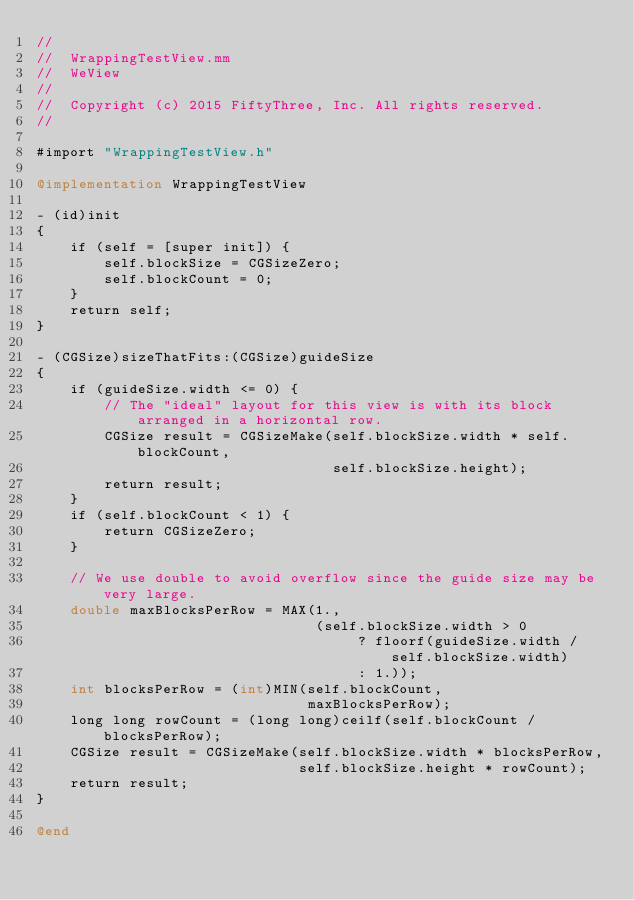<code> <loc_0><loc_0><loc_500><loc_500><_ObjectiveC_>//
//  WrappingTestView.mm
//  WeView
//
//  Copyright (c) 2015 FiftyThree, Inc. All rights reserved.
//

#import "WrappingTestView.h"

@implementation WrappingTestView

- (id)init
{
    if (self = [super init]) {
        self.blockSize = CGSizeZero;
        self.blockCount = 0;
    }
    return self;
}

- (CGSize)sizeThatFits:(CGSize)guideSize
{
    if (guideSize.width <= 0) {
        // The "ideal" layout for this view is with its block arranged in a horizontal row.
        CGSize result = CGSizeMake(self.blockSize.width * self.blockCount,
                                   self.blockSize.height);
        return result;
    }
    if (self.blockCount < 1) {
        return CGSizeZero;
    }

    // We use double to avoid overflow since the guide size may be very large.
    double maxBlocksPerRow = MAX(1.,
                                 (self.blockSize.width > 0
                                      ? floorf(guideSize.width / self.blockSize.width)
                                      : 1.));
    int blocksPerRow = (int)MIN(self.blockCount,
                                maxBlocksPerRow);
    long long rowCount = (long long)ceilf(self.blockCount / blocksPerRow);
    CGSize result = CGSizeMake(self.blockSize.width * blocksPerRow,
                               self.blockSize.height * rowCount);
    return result;
}

@end
</code> 